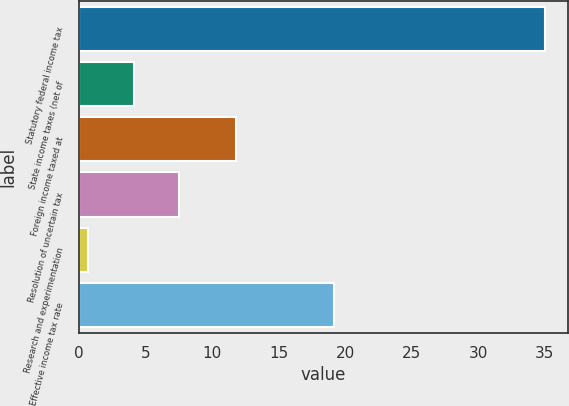<chart> <loc_0><loc_0><loc_500><loc_500><bar_chart><fcel>Statutory federal income tax<fcel>State income taxes (net of<fcel>Foreign income taxed at<fcel>Resolution of uncertain tax<fcel>Research and experimentation<fcel>Effective income tax rate<nl><fcel>35<fcel>4.13<fcel>11.8<fcel>7.56<fcel>0.7<fcel>19.2<nl></chart> 